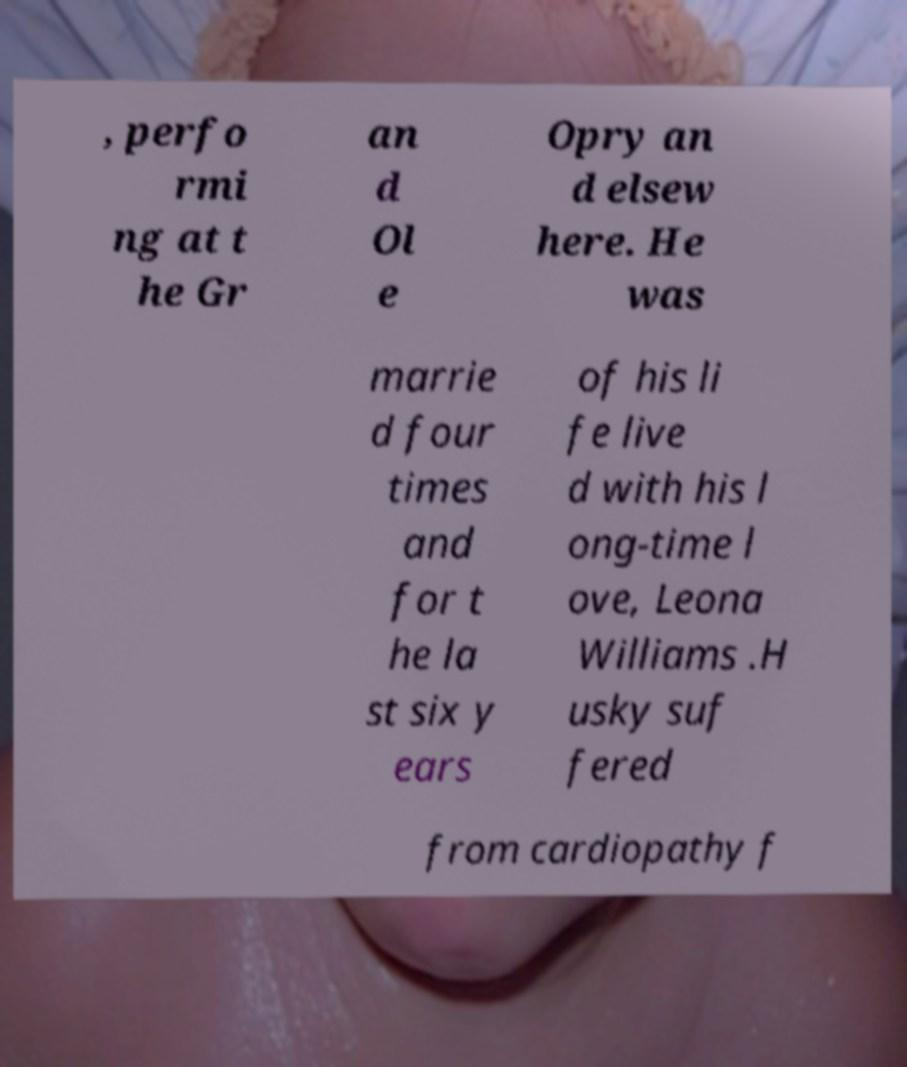Can you accurately transcribe the text from the provided image for me? , perfo rmi ng at t he Gr an d Ol e Opry an d elsew here. He was marrie d four times and for t he la st six y ears of his li fe live d with his l ong-time l ove, Leona Williams .H usky suf fered from cardiopathy f 